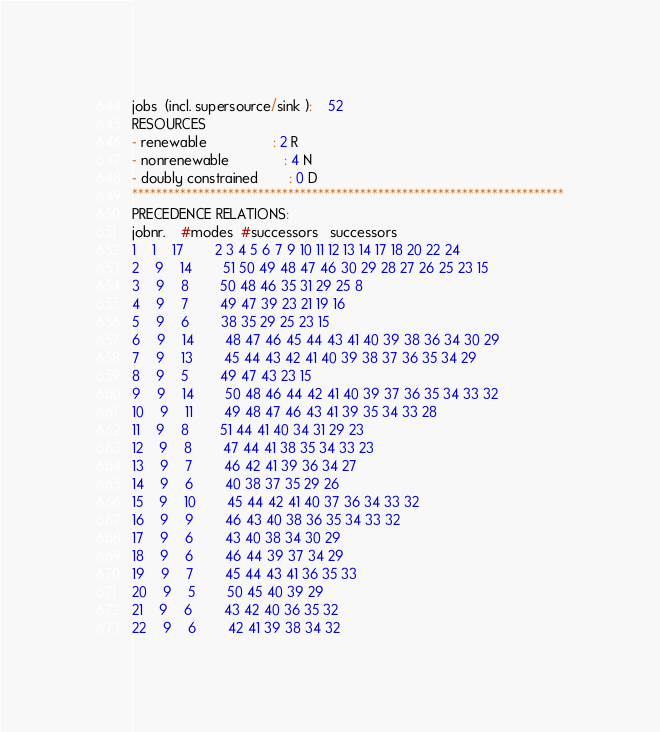Convert code to text. <code><loc_0><loc_0><loc_500><loc_500><_ObjectiveC_>jobs  (incl. supersource/sink ):	52
RESOURCES
- renewable                 : 2 R
- nonrenewable              : 4 N
- doubly constrained        : 0 D
************************************************************************
PRECEDENCE RELATIONS:
jobnr.    #modes  #successors   successors
1	1	17		2 3 4 5 6 7 9 10 11 12 13 14 17 18 20 22 24 
2	9	14		51 50 49 48 47 46 30 29 28 27 26 25 23 15 
3	9	8		50 48 46 35 31 29 25 8 
4	9	7		49 47 39 23 21 19 16 
5	9	6		38 35 29 25 23 15 
6	9	14		48 47 46 45 44 43 41 40 39 38 36 34 30 29 
7	9	13		45 44 43 42 41 40 39 38 37 36 35 34 29 
8	9	5		49 47 43 23 15 
9	9	14		50 48 46 44 42 41 40 39 37 36 35 34 33 32 
10	9	11		49 48 47 46 43 41 39 35 34 33 28 
11	9	8		51 44 41 40 34 31 29 23 
12	9	8		47 44 41 38 35 34 33 23 
13	9	7		46 42 41 39 36 34 27 
14	9	6		40 38 37 35 29 26 
15	9	10		45 44 42 41 40 37 36 34 33 32 
16	9	9		46 43 40 38 36 35 34 33 32 
17	9	6		43 40 38 34 30 29 
18	9	6		46 44 39 37 34 29 
19	9	7		45 44 43 41 36 35 33 
20	9	5		50 45 40 39 29 
21	9	6		43 42 40 36 35 32 
22	9	6		42 41 39 38 34 32 </code> 